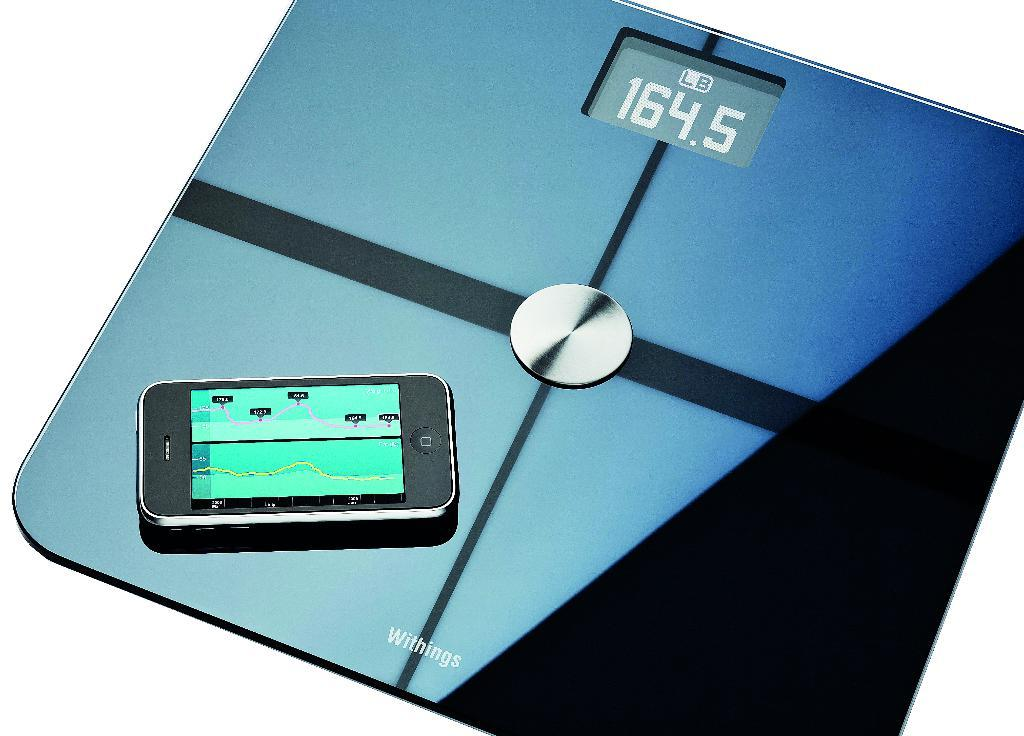<image>
Relay a brief, clear account of the picture shown. A scale that says 164.5 pounds is displayed 